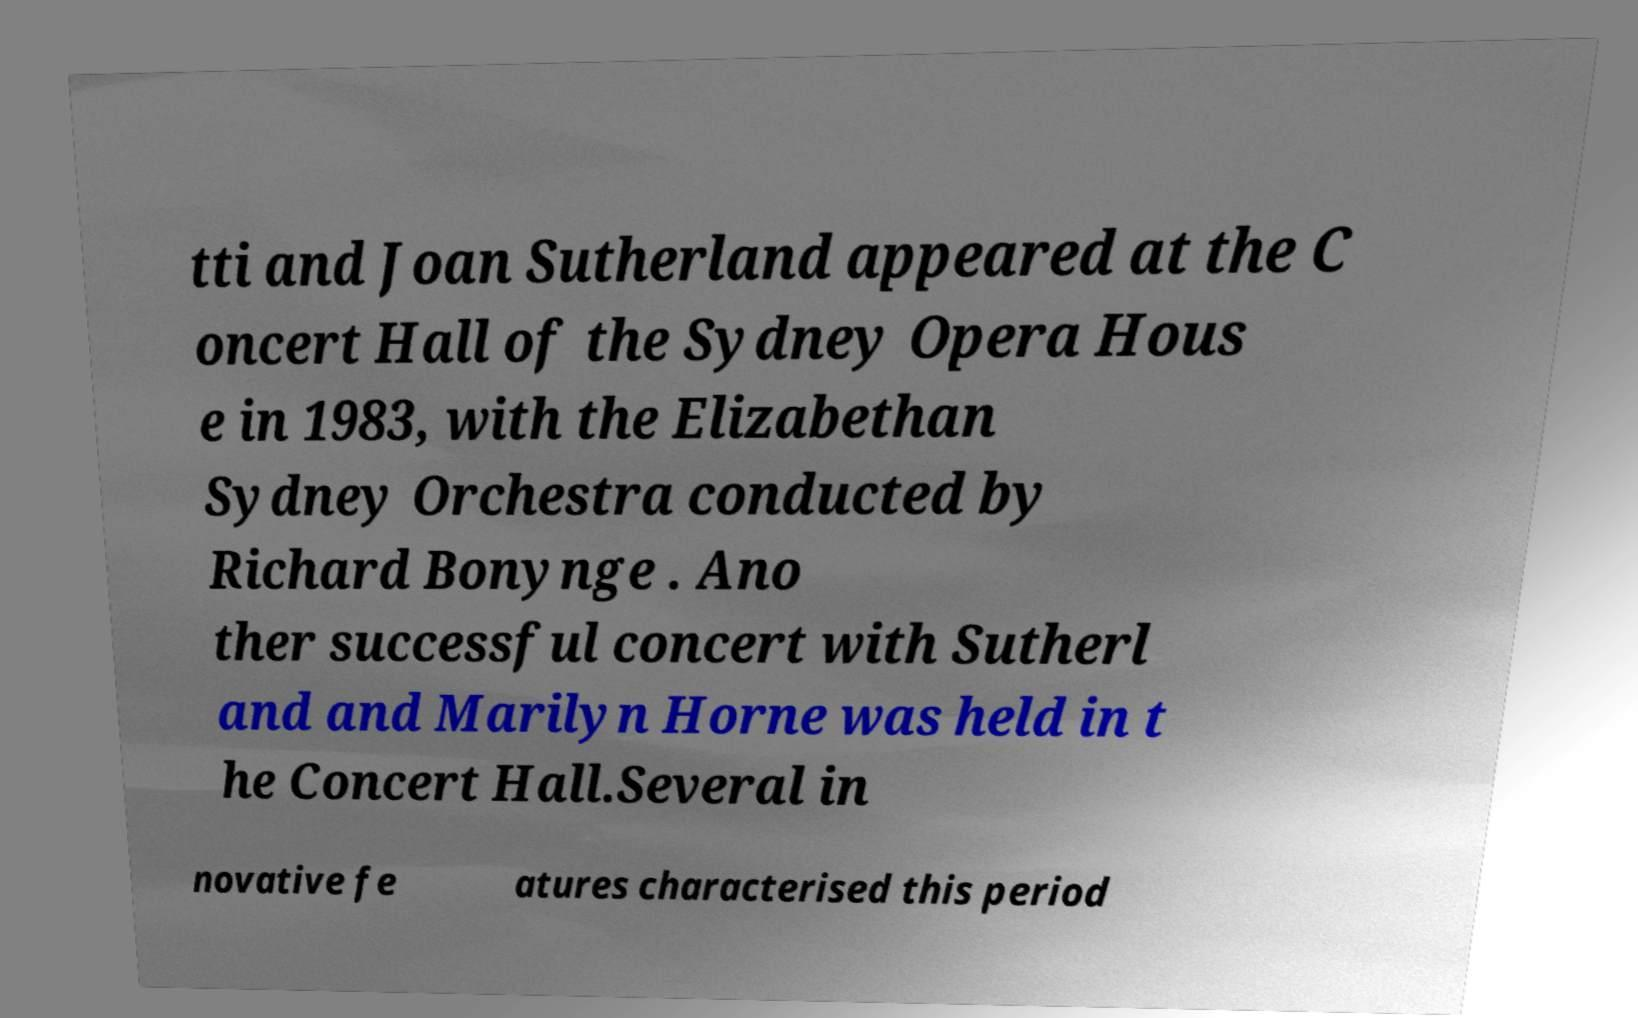Please read and relay the text visible in this image. What does it say? tti and Joan Sutherland appeared at the C oncert Hall of the Sydney Opera Hous e in 1983, with the Elizabethan Sydney Orchestra conducted by Richard Bonynge . Ano ther successful concert with Sutherl and and Marilyn Horne was held in t he Concert Hall.Several in novative fe atures characterised this period 